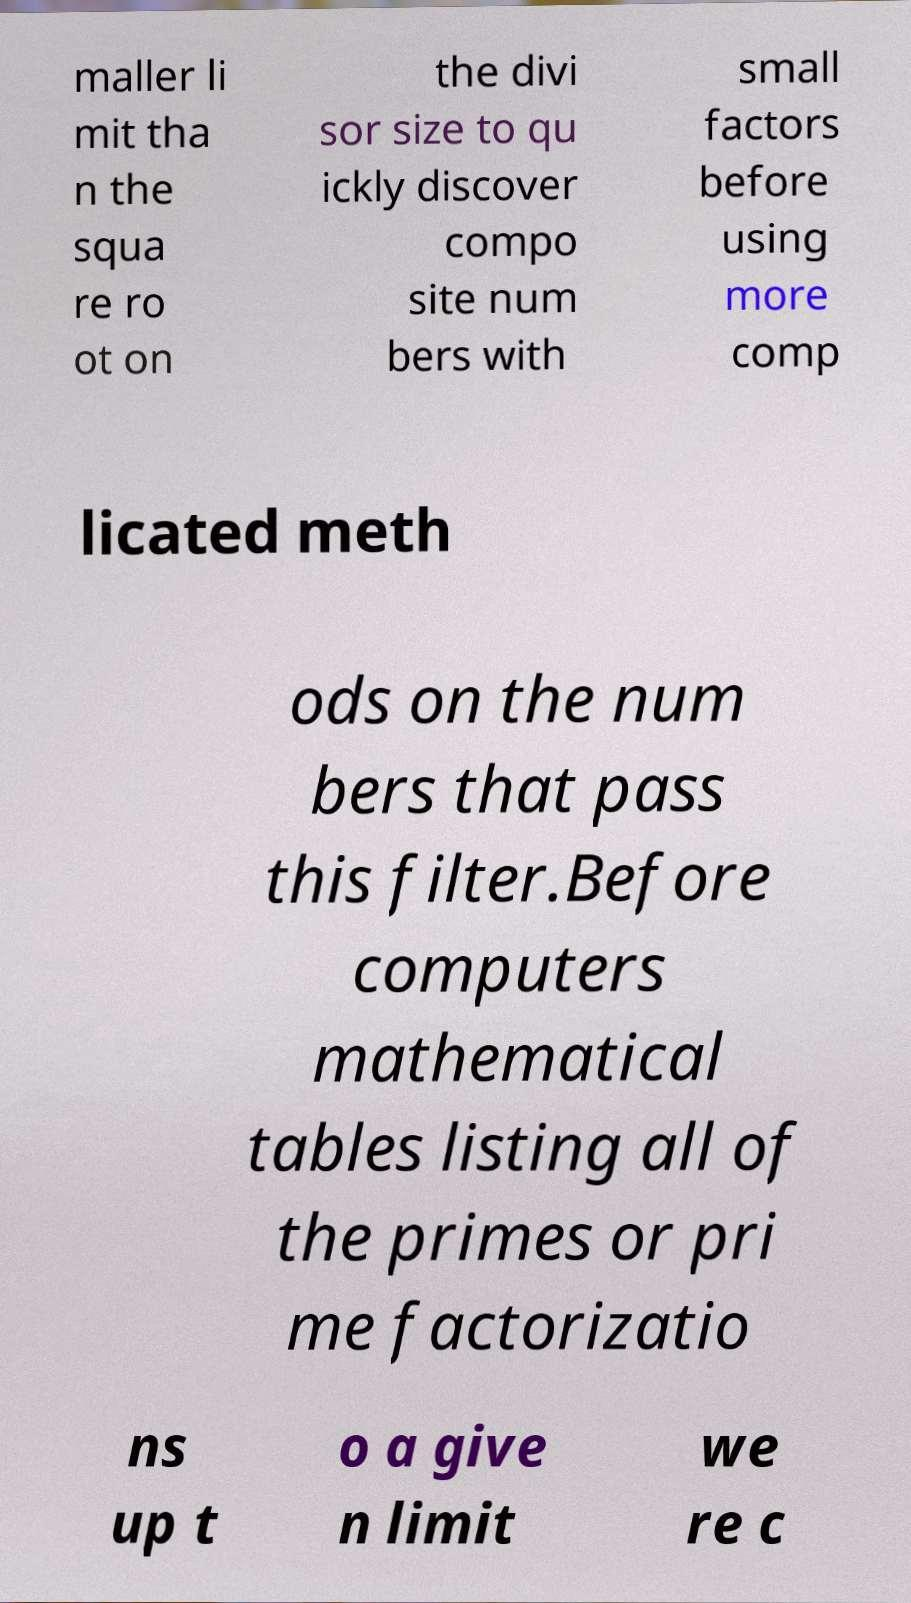Could you extract and type out the text from this image? maller li mit tha n the squa re ro ot on the divi sor size to qu ickly discover compo site num bers with small factors before using more comp licated meth ods on the num bers that pass this filter.Before computers mathematical tables listing all of the primes or pri me factorizatio ns up t o a give n limit we re c 